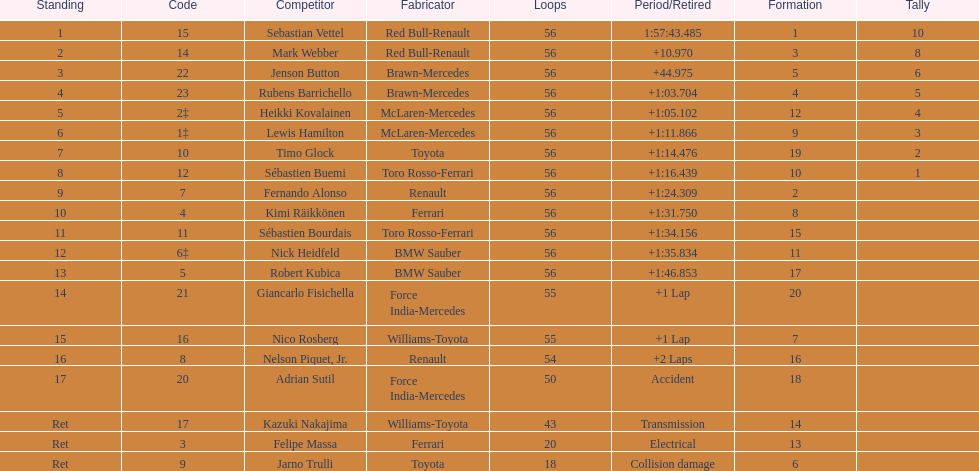Who was the slowest driver to finish the race? Robert Kubica. 